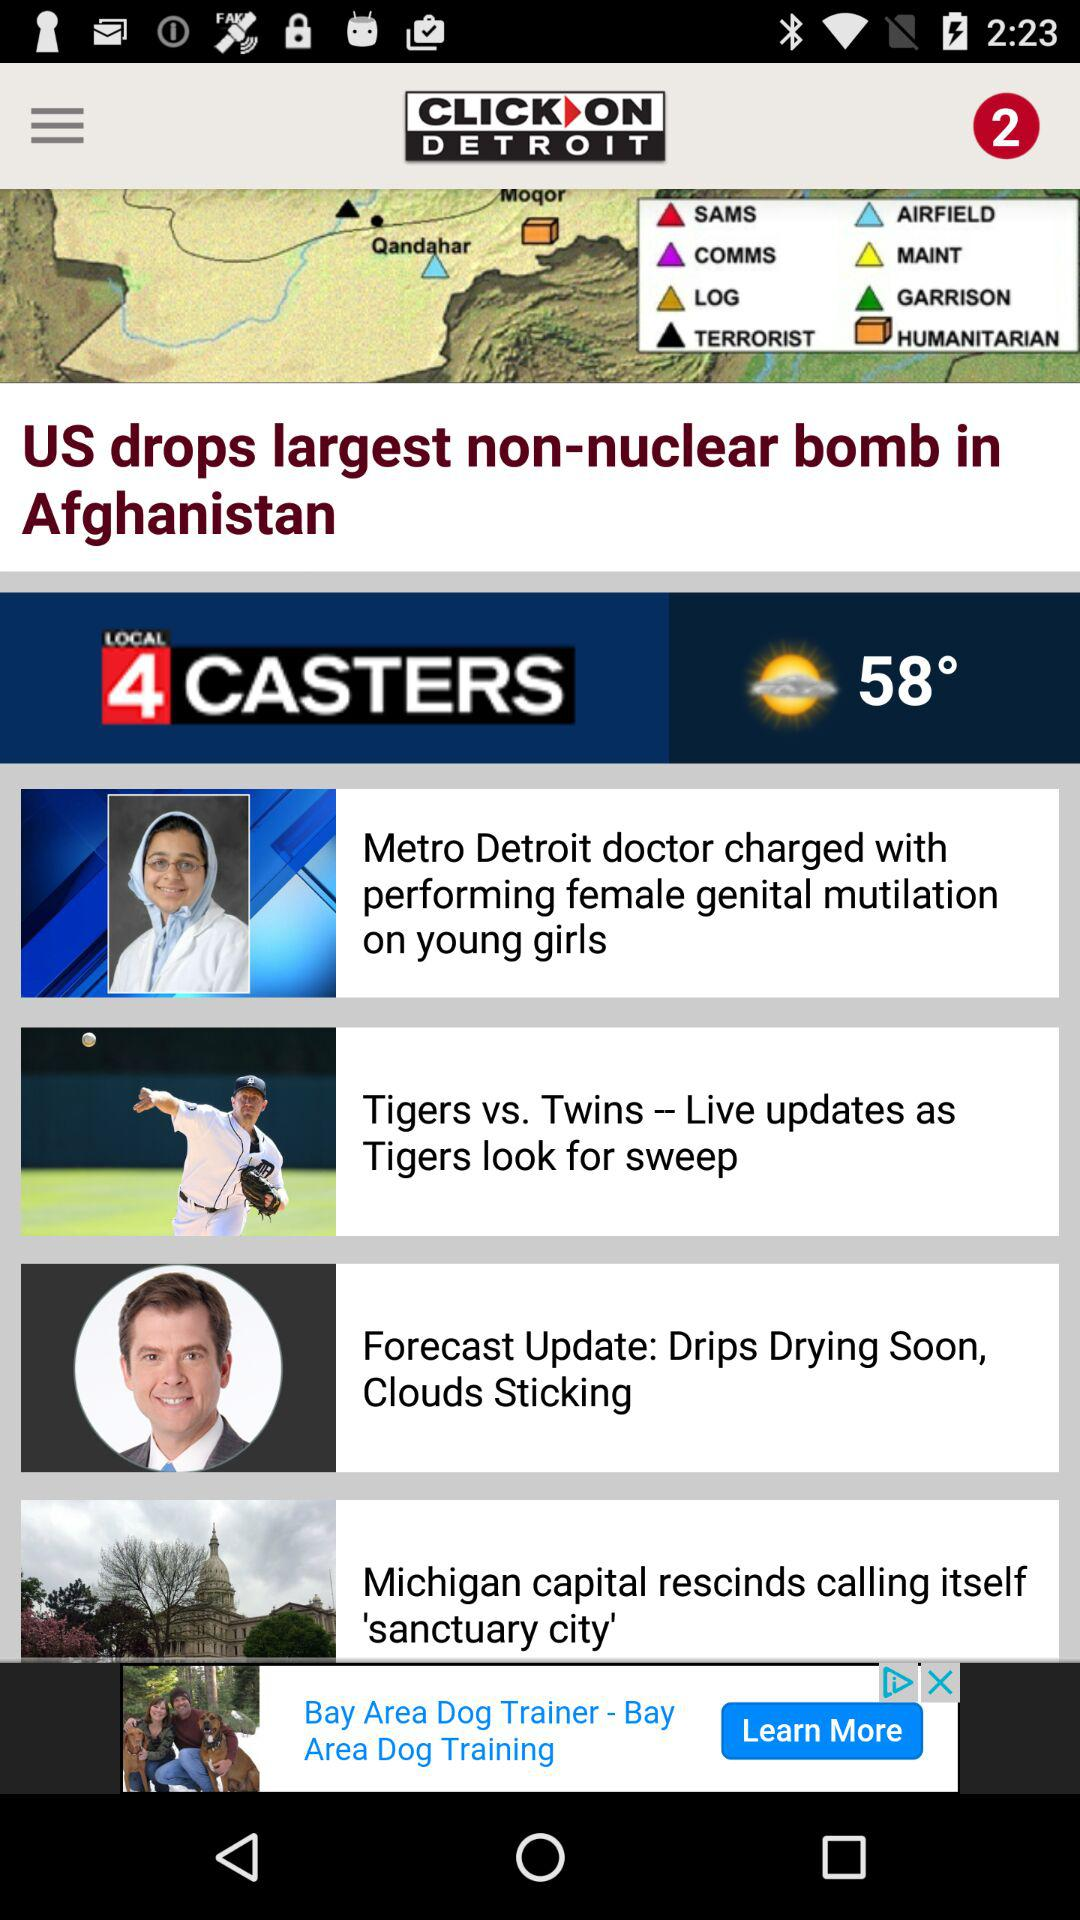What is the temperature? The temperature is "58°". 